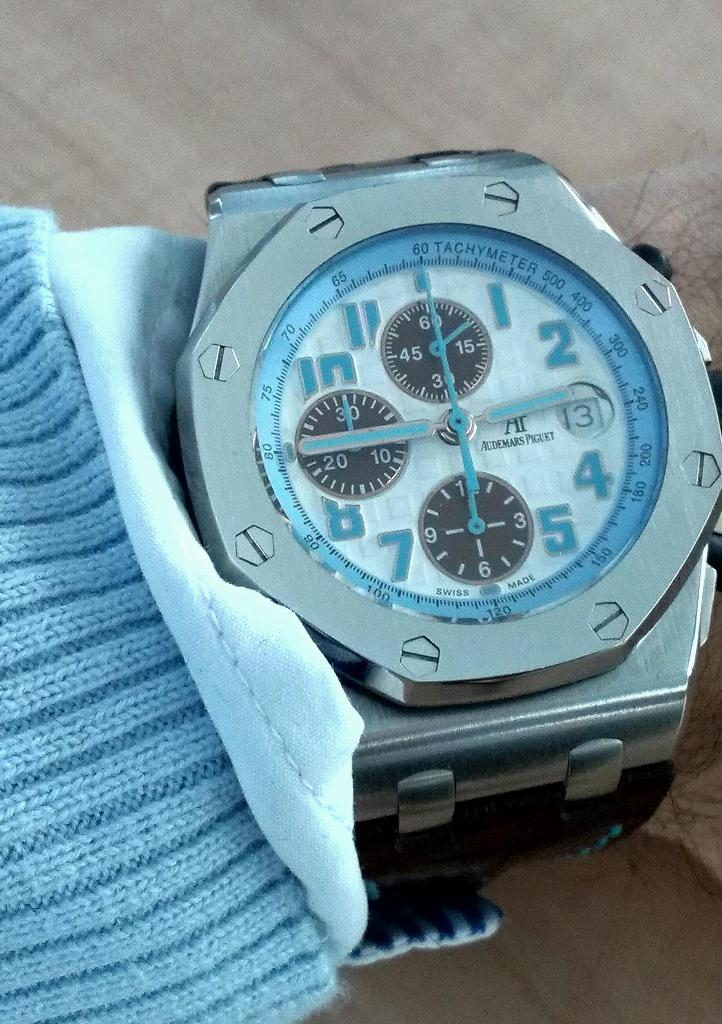Provide a one-sentence caption for the provided image. A silver, white, and light blue watch with "Swiss Made" written across the bottom. 